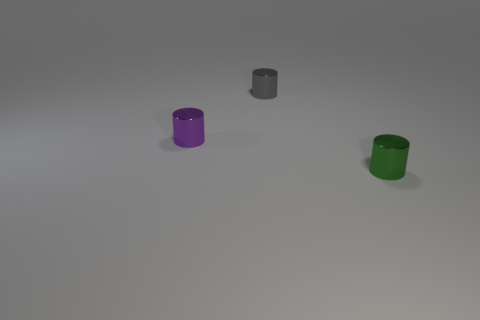What is the material of the green object that is the same shape as the tiny gray thing?
Provide a succinct answer. Metal. Does the thing that is in front of the purple shiny object have the same shape as the tiny object behind the tiny purple cylinder?
Ensure brevity in your answer.  Yes. Is the number of gray metal objects behind the purple cylinder greater than the number of tiny brown matte balls?
Provide a short and direct response. Yes. What number of things are green cylinders or tiny metallic things?
Your answer should be compact. 3. Are there any metallic cylinders behind the tiny gray shiny cylinder?
Provide a succinct answer. No. The thing right of the tiny shiny thing behind the thing left of the small gray shiny object is what color?
Offer a terse response. Green. How many small metal cylinders are in front of the tiny gray metallic object and to the right of the tiny purple cylinder?
Keep it short and to the point. 1. What number of cylinders are either small green objects or gray rubber things?
Provide a succinct answer. 1. Are there any tiny brown rubber cubes?
Keep it short and to the point. No. What is the material of the purple cylinder that is the same size as the gray object?
Your response must be concise. Metal. 